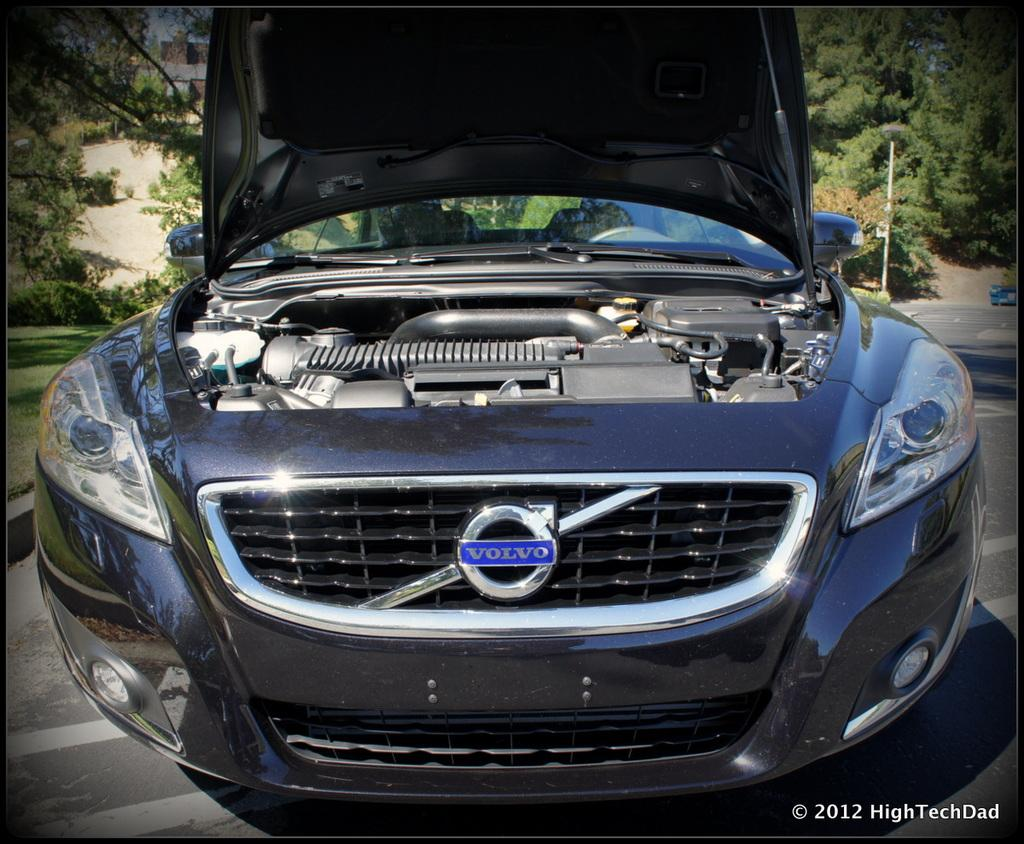What is the main subject of the image? There is a vehicle on the road in the image. What can be seen in the background of the image? Trees, grass, and buildings are visible in the image. What color is the tongue of the person driving the vehicle in the image? There is no person or tongue visible in the image; it only shows a vehicle on the road. 